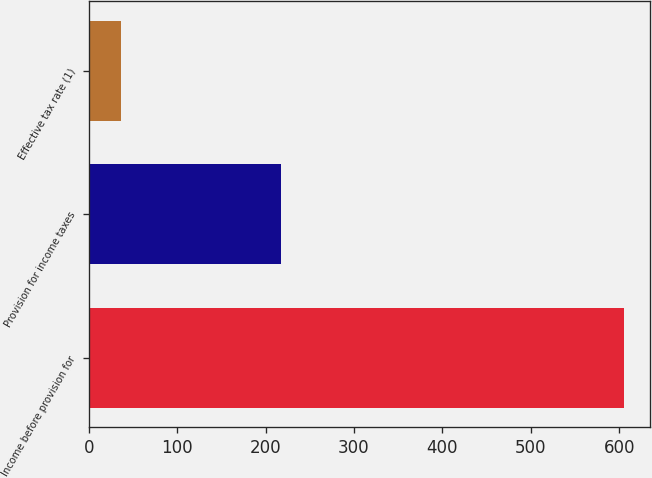Convert chart. <chart><loc_0><loc_0><loc_500><loc_500><bar_chart><fcel>Income before provision for<fcel>Provision for income taxes<fcel>Effective tax rate (1)<nl><fcel>605<fcel>218<fcel>36<nl></chart> 